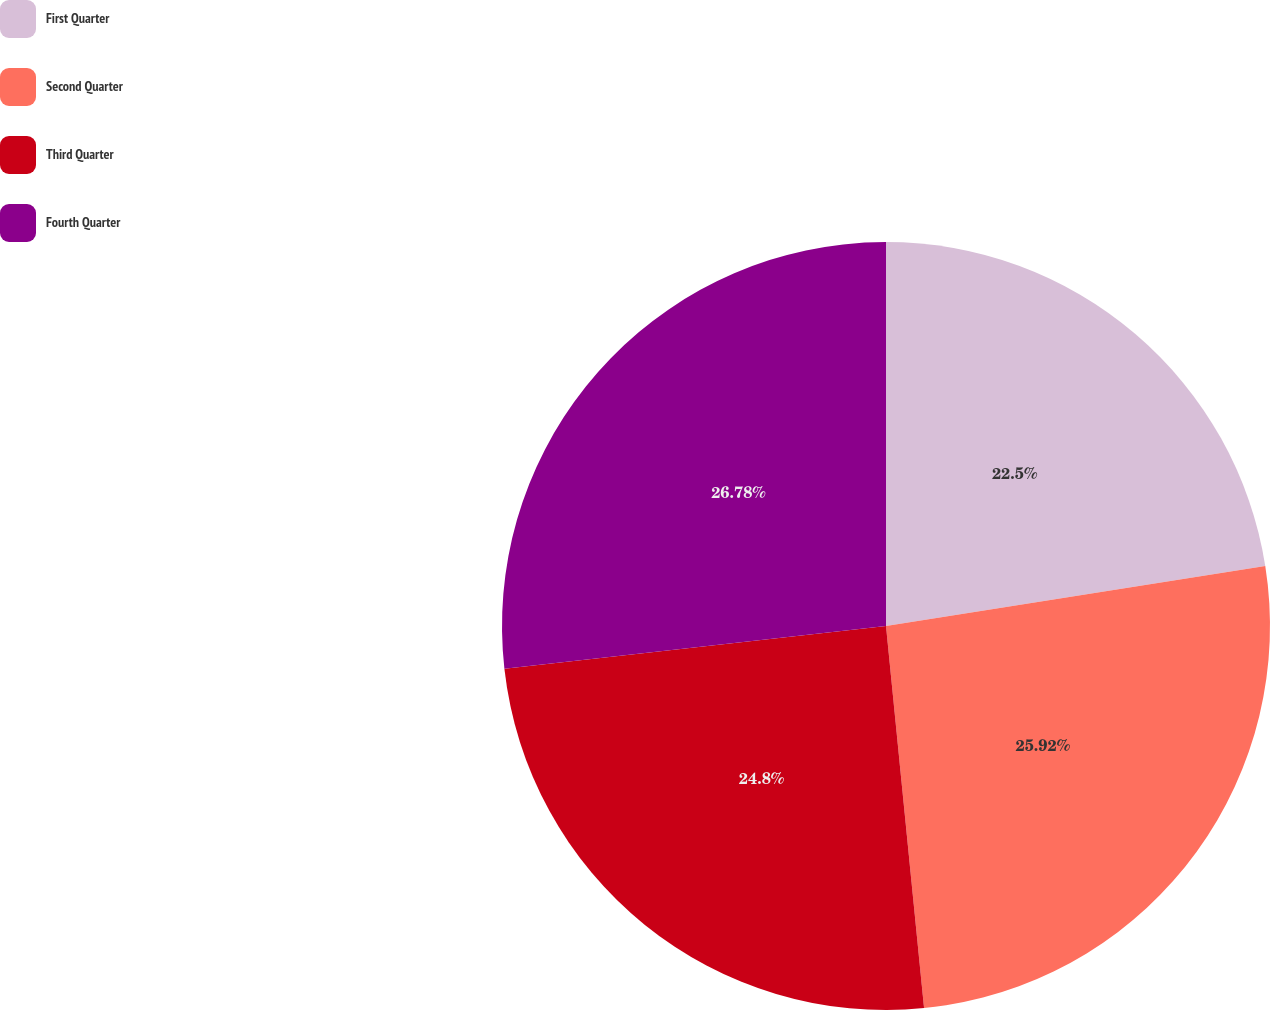<chart> <loc_0><loc_0><loc_500><loc_500><pie_chart><fcel>First Quarter<fcel>Second Quarter<fcel>Third Quarter<fcel>Fourth Quarter<nl><fcel>22.5%<fcel>25.92%<fcel>24.8%<fcel>26.78%<nl></chart> 